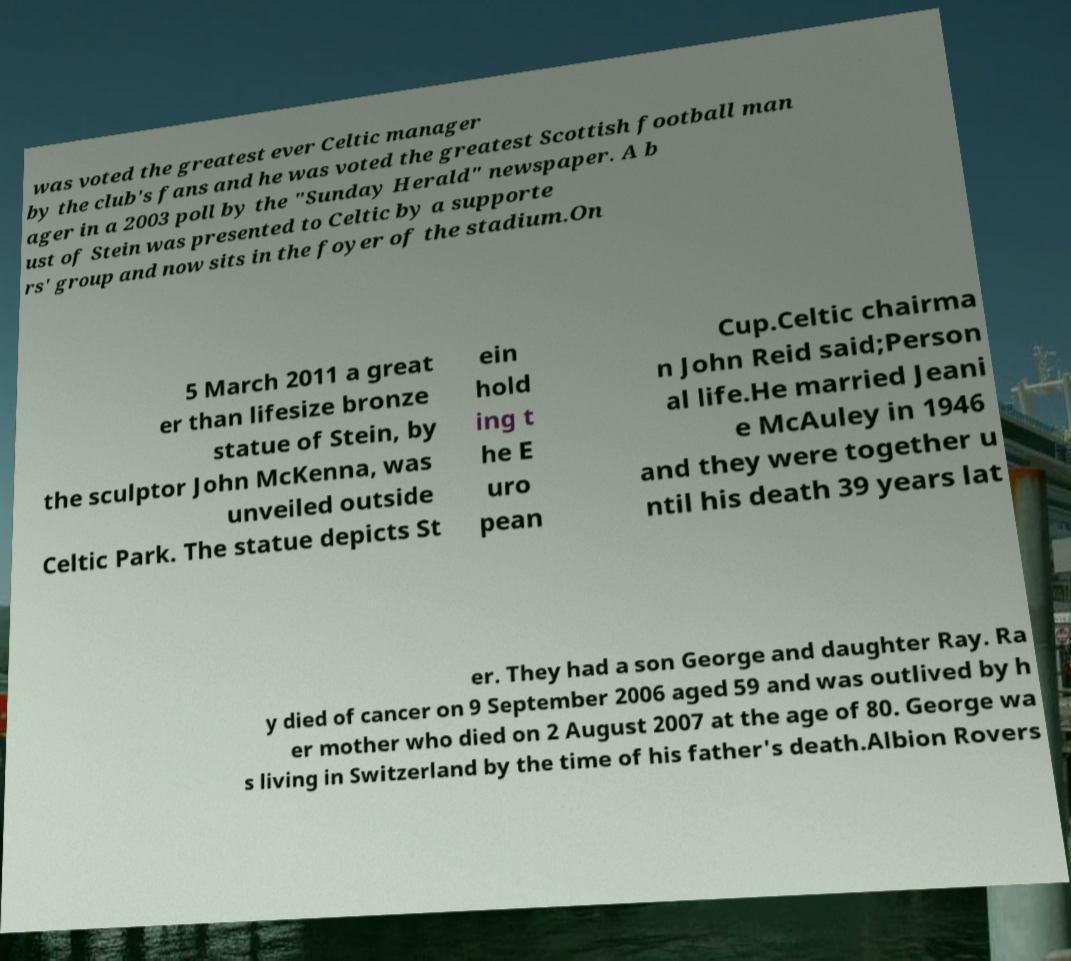Could you extract and type out the text from this image? was voted the greatest ever Celtic manager by the club's fans and he was voted the greatest Scottish football man ager in a 2003 poll by the "Sunday Herald" newspaper. A b ust of Stein was presented to Celtic by a supporte rs' group and now sits in the foyer of the stadium.On 5 March 2011 a great er than lifesize bronze statue of Stein, by the sculptor John McKenna, was unveiled outside Celtic Park. The statue depicts St ein hold ing t he E uro pean Cup.Celtic chairma n John Reid said;Person al life.He married Jeani e McAuley in 1946 and they were together u ntil his death 39 years lat er. They had a son George and daughter Ray. Ra y died of cancer on 9 September 2006 aged 59 and was outlived by h er mother who died on 2 August 2007 at the age of 80. George wa s living in Switzerland by the time of his father's death.Albion Rovers 